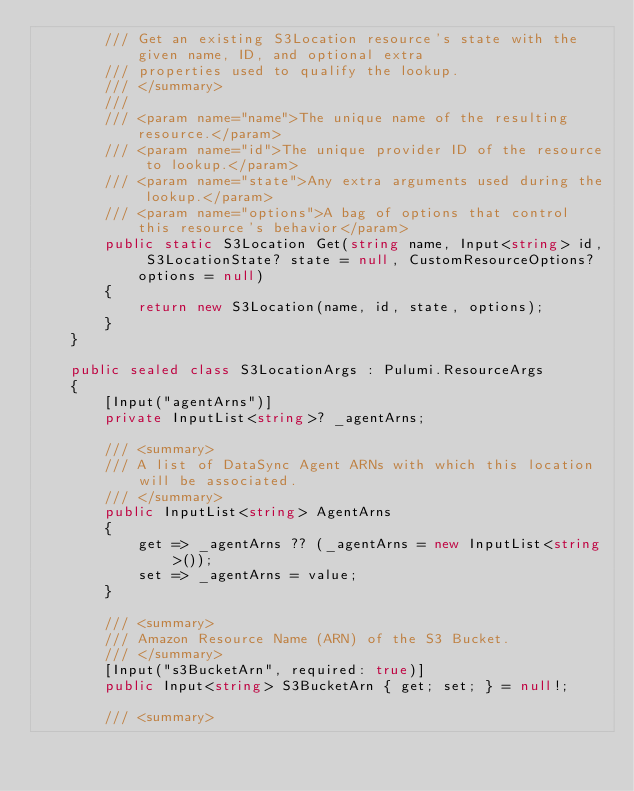<code> <loc_0><loc_0><loc_500><loc_500><_C#_>        /// Get an existing S3Location resource's state with the given name, ID, and optional extra
        /// properties used to qualify the lookup.
        /// </summary>
        ///
        /// <param name="name">The unique name of the resulting resource.</param>
        /// <param name="id">The unique provider ID of the resource to lookup.</param>
        /// <param name="state">Any extra arguments used during the lookup.</param>
        /// <param name="options">A bag of options that control this resource's behavior</param>
        public static S3Location Get(string name, Input<string> id, S3LocationState? state = null, CustomResourceOptions? options = null)
        {
            return new S3Location(name, id, state, options);
        }
    }

    public sealed class S3LocationArgs : Pulumi.ResourceArgs
    {
        [Input("agentArns")]
        private InputList<string>? _agentArns;

        /// <summary>
        /// A list of DataSync Agent ARNs with which this location will be associated.
        /// </summary>
        public InputList<string> AgentArns
        {
            get => _agentArns ?? (_agentArns = new InputList<string>());
            set => _agentArns = value;
        }

        /// <summary>
        /// Amazon Resource Name (ARN) of the S3 Bucket.
        /// </summary>
        [Input("s3BucketArn", required: true)]
        public Input<string> S3BucketArn { get; set; } = null!;

        /// <summary></code> 